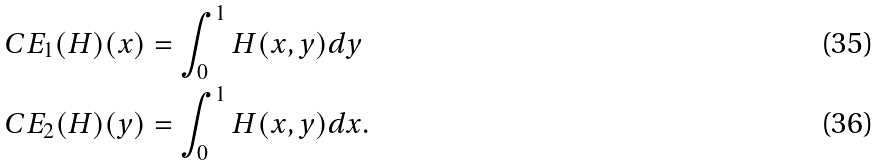<formula> <loc_0><loc_0><loc_500><loc_500>C E _ { 1 } ( H ) ( x ) & = \int _ { 0 } ^ { 1 } H ( x , y ) d y \\ C E _ { 2 } ( H ) ( y ) & = \int _ { 0 } ^ { 1 } H ( x , y ) d x .</formula> 